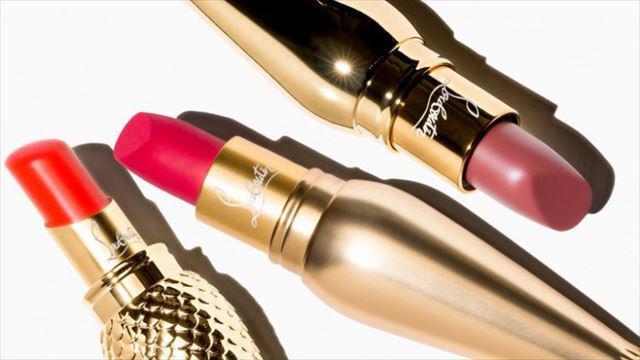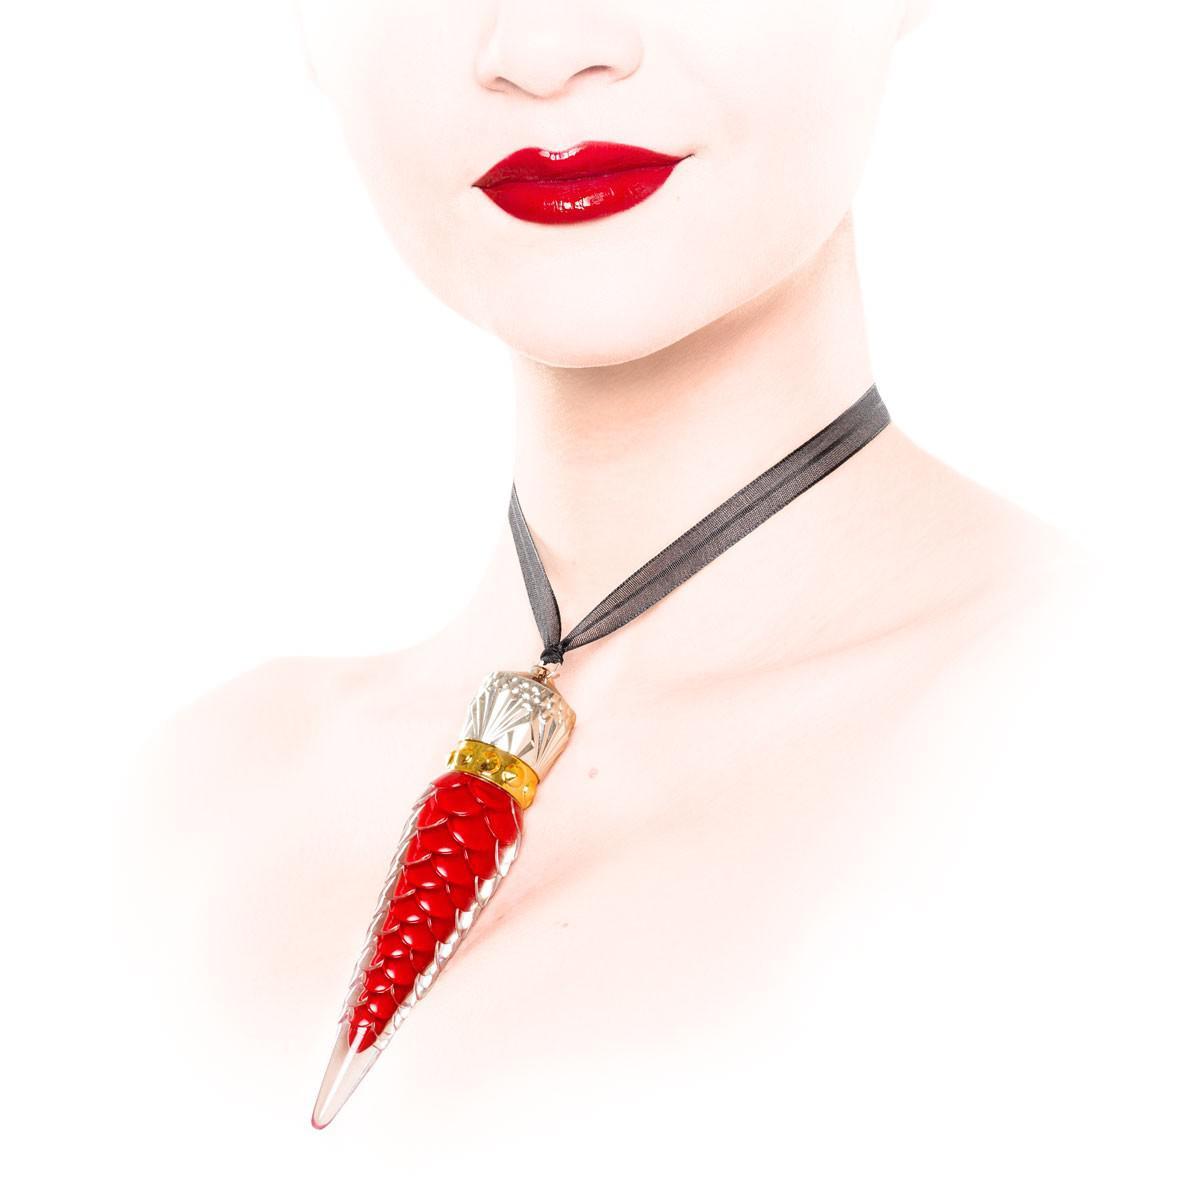The first image is the image on the left, the second image is the image on the right. Assess this claim about the two images: "There are at least five cone shaped lipstick containers in the image on the left.". Correct or not? Answer yes or no. No. The first image is the image on the left, the second image is the image on the right. Assess this claim about the two images: "An image shows at least eight ornament-shaped lipsticks in various shades.". Correct or not? Answer yes or no. No. 